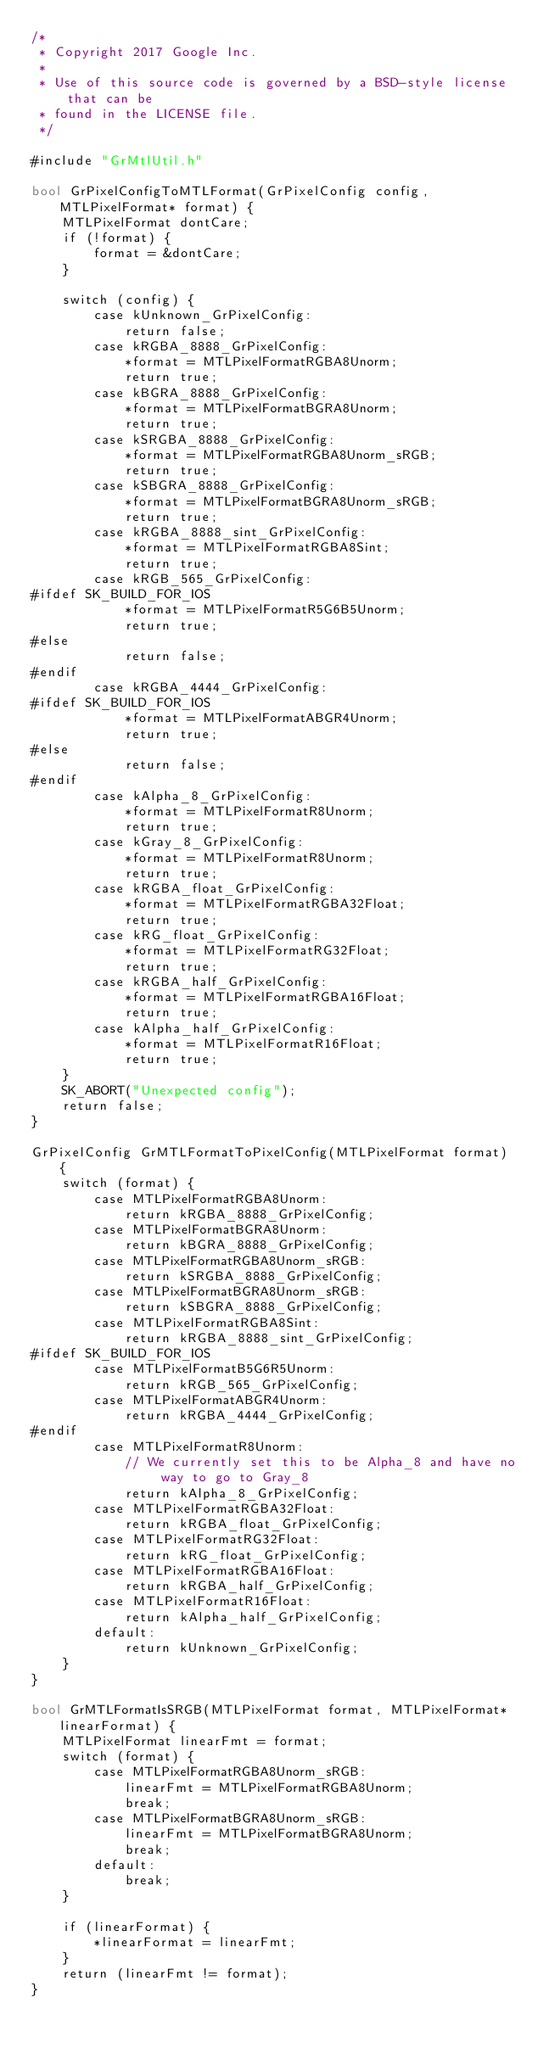<code> <loc_0><loc_0><loc_500><loc_500><_ObjectiveC_>/*
 * Copyright 2017 Google Inc.
 *
 * Use of this source code is governed by a BSD-style license that can be
 * found in the LICENSE file.
 */

#include "GrMtlUtil.h"

bool GrPixelConfigToMTLFormat(GrPixelConfig config, MTLPixelFormat* format) {
    MTLPixelFormat dontCare;
    if (!format) {
        format = &dontCare;
    }

    switch (config) {
        case kUnknown_GrPixelConfig:
            return false;
        case kRGBA_8888_GrPixelConfig:
            *format = MTLPixelFormatRGBA8Unorm;
            return true;
        case kBGRA_8888_GrPixelConfig:
            *format = MTLPixelFormatBGRA8Unorm;
            return true;
        case kSRGBA_8888_GrPixelConfig:
            *format = MTLPixelFormatRGBA8Unorm_sRGB;
            return true;
        case kSBGRA_8888_GrPixelConfig:
            *format = MTLPixelFormatBGRA8Unorm_sRGB;
            return true;
        case kRGBA_8888_sint_GrPixelConfig:
            *format = MTLPixelFormatRGBA8Sint;
            return true;
        case kRGB_565_GrPixelConfig:
#ifdef SK_BUILD_FOR_IOS
            *format = MTLPixelFormatR5G6B5Unorm;
            return true;
#else
            return false;
#endif
        case kRGBA_4444_GrPixelConfig:
#ifdef SK_BUILD_FOR_IOS
            *format = MTLPixelFormatABGR4Unorm;
            return true;
#else
            return false;
#endif
        case kAlpha_8_GrPixelConfig:
            *format = MTLPixelFormatR8Unorm;
            return true;
        case kGray_8_GrPixelConfig:
            *format = MTLPixelFormatR8Unorm;
            return true;
        case kRGBA_float_GrPixelConfig:
            *format = MTLPixelFormatRGBA32Float;
            return true;
        case kRG_float_GrPixelConfig:
            *format = MTLPixelFormatRG32Float;
            return true;
        case kRGBA_half_GrPixelConfig:
            *format = MTLPixelFormatRGBA16Float;
            return true;
        case kAlpha_half_GrPixelConfig:
            *format = MTLPixelFormatR16Float;
            return true;
    }
    SK_ABORT("Unexpected config");
    return false;
}

GrPixelConfig GrMTLFormatToPixelConfig(MTLPixelFormat format) {
    switch (format) {
        case MTLPixelFormatRGBA8Unorm:
            return kRGBA_8888_GrPixelConfig;
        case MTLPixelFormatBGRA8Unorm:
            return kBGRA_8888_GrPixelConfig;
        case MTLPixelFormatRGBA8Unorm_sRGB:
            return kSRGBA_8888_GrPixelConfig;
        case MTLPixelFormatBGRA8Unorm_sRGB:
            return kSBGRA_8888_GrPixelConfig;
        case MTLPixelFormatRGBA8Sint:
            return kRGBA_8888_sint_GrPixelConfig;
#ifdef SK_BUILD_FOR_IOS
        case MTLPixelFormatB5G6R5Unorm:
            return kRGB_565_GrPixelConfig;
        case MTLPixelFormatABGR4Unorm:
            return kRGBA_4444_GrPixelConfig;
#endif
        case MTLPixelFormatR8Unorm:
            // We currently set this to be Alpha_8 and have no way to go to Gray_8
            return kAlpha_8_GrPixelConfig;
        case MTLPixelFormatRGBA32Float:
            return kRGBA_float_GrPixelConfig;
        case MTLPixelFormatRG32Float:
            return kRG_float_GrPixelConfig;
        case MTLPixelFormatRGBA16Float:
            return kRGBA_half_GrPixelConfig;
        case MTLPixelFormatR16Float:
            return kAlpha_half_GrPixelConfig;
        default:
            return kUnknown_GrPixelConfig;
    }
}

bool GrMTLFormatIsSRGB(MTLPixelFormat format, MTLPixelFormat* linearFormat) {
    MTLPixelFormat linearFmt = format;
    switch (format) {
        case MTLPixelFormatRGBA8Unorm_sRGB:
            linearFmt = MTLPixelFormatRGBA8Unorm;
            break;
        case MTLPixelFormatBGRA8Unorm_sRGB:
            linearFmt = MTLPixelFormatBGRA8Unorm;
            break;
        default:
            break;
    }

    if (linearFormat) {
        *linearFormat = linearFmt;
    }
    return (linearFmt != format);
}

</code> 